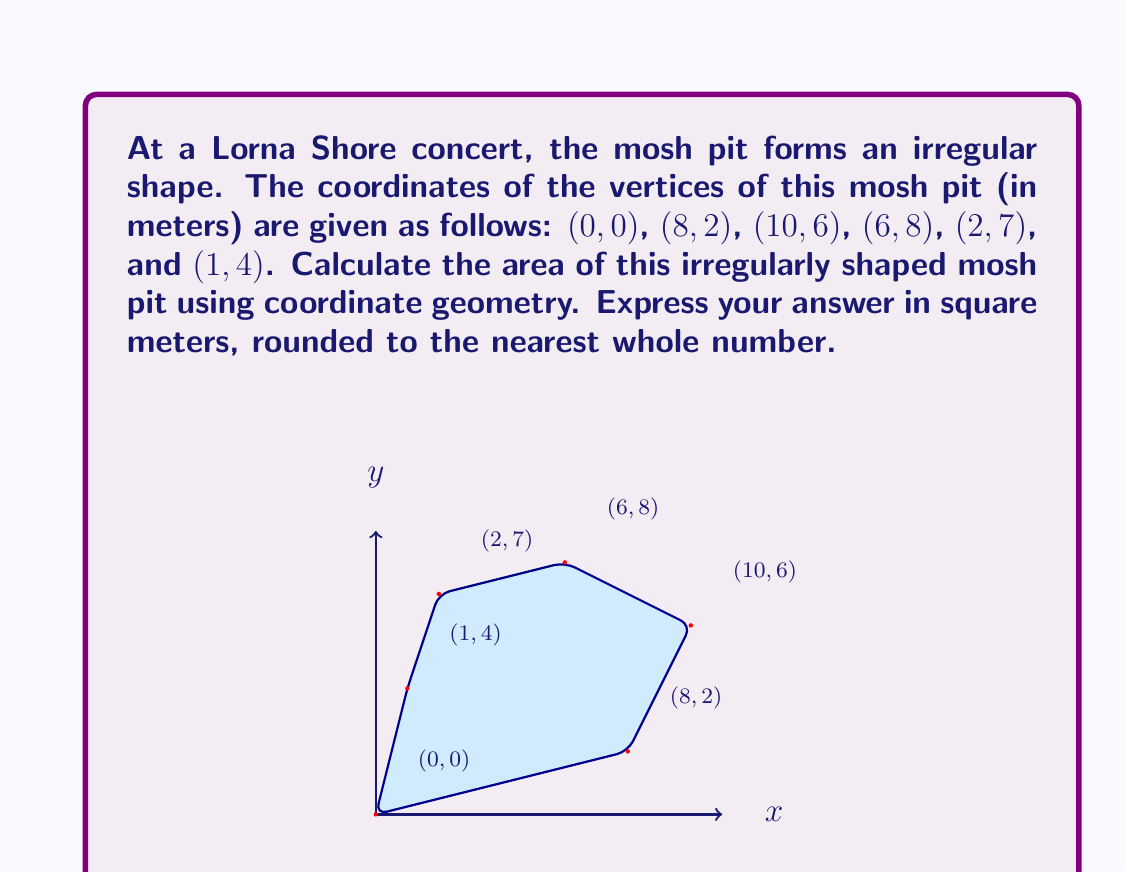Show me your answer to this math problem. To solve this problem, we can use the Shoelace formula (also known as the surveyor's formula) to calculate the area of an irregular polygon given its vertices.

The formula is:

$$ A = \frac{1}{2}\left|\sum_{i=1}^{n-1} (x_iy_{i+1} - x_{i+1}y_i) + (x_ny_1 - x_1y_n)\right| $$

Where $(x_i, y_i)$ are the coordinates of the $i$-th vertex.

Let's apply this formula to our mosh pit coordinates:

1) First, let's organize our data:
   $(x_1, y_1) = (0, 0)$
   $(x_2, y_2) = (8, 2)$
   $(x_3, y_3) = (10, 6)$
   $(x_4, y_4) = (6, 8)$
   $(x_5, y_5) = (2, 7)$
   $(x_6, y_6) = (1, 4)$

2) Now, let's calculate each term in the sum:
   $0 \cdot 2 - 8 \cdot 0 = 0$
   $8 \cdot 6 - 10 \cdot 2 = 28$
   $10 \cdot 8 - 6 \cdot 6 = 44$
   $6 \cdot 7 - 2 \cdot 8 = 26$
   $2 \cdot 4 - 1 \cdot 7 = 1$
   $1 \cdot 0 - 0 \cdot 4 = 0$

3) Sum these terms:
   $0 + 28 + 44 + 26 + 1 + 0 = 99$

4) Multiply by $\frac{1}{2}$:
   $\frac{1}{2} \cdot 99 = 49.5$

Therefore, the area of the mosh pit is 49.5 square meters.

Rounding to the nearest whole number gives us 50 square meters.
Answer: 50 square meters 